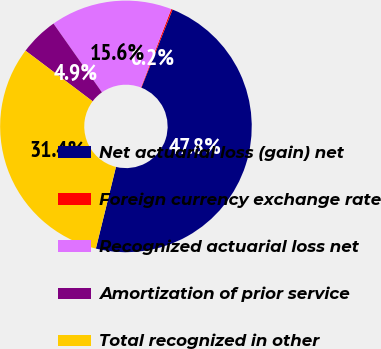Convert chart to OTSL. <chart><loc_0><loc_0><loc_500><loc_500><pie_chart><fcel>Net actuarial loss (gain) net<fcel>Foreign currency exchange rate<fcel>Recognized actuarial loss net<fcel>Amortization of prior service<fcel>Total recognized in other<nl><fcel>47.8%<fcel>0.18%<fcel>15.63%<fcel>4.95%<fcel>31.44%<nl></chart> 